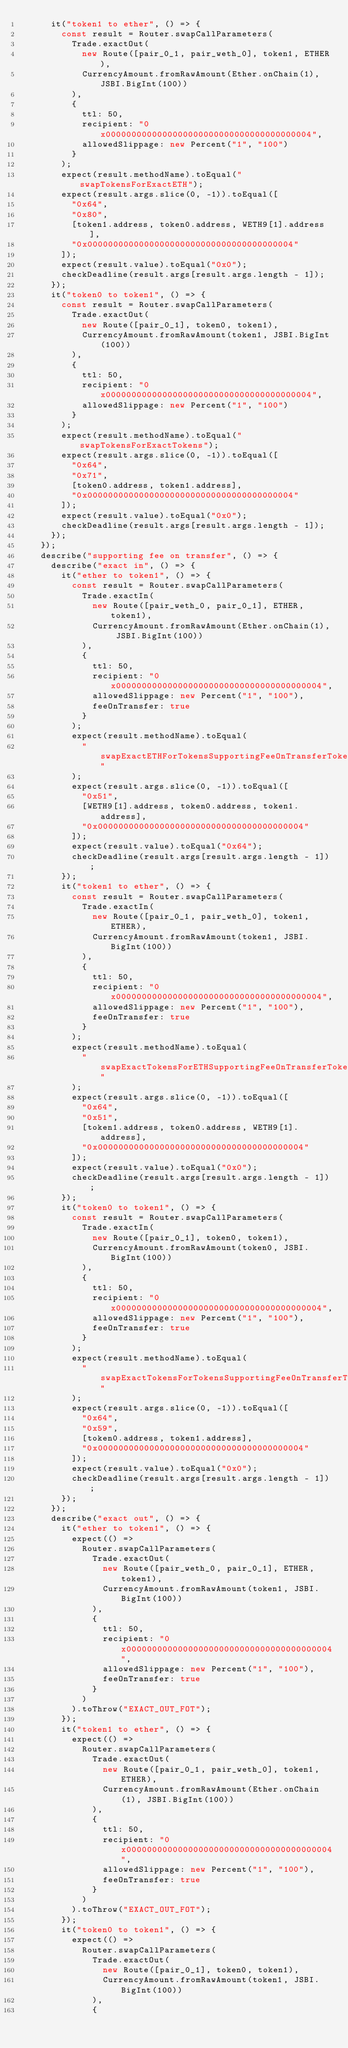Convert code to text. <code><loc_0><loc_0><loc_500><loc_500><_TypeScript_>      it("token1 to ether", () => {
        const result = Router.swapCallParameters(
          Trade.exactOut(
            new Route([pair_0_1, pair_weth_0], token1, ETHER),
            CurrencyAmount.fromRawAmount(Ether.onChain(1), JSBI.BigInt(100))
          ),
          {
            ttl: 50,
            recipient: "0x0000000000000000000000000000000000000004",
            allowedSlippage: new Percent("1", "100")
          }
        );
        expect(result.methodName).toEqual("swapTokensForExactETH");
        expect(result.args.slice(0, -1)).toEqual([
          "0x64",
          "0x80",
          [token1.address, token0.address, WETH9[1].address],
          "0x0000000000000000000000000000000000000004"
        ]);
        expect(result.value).toEqual("0x0");
        checkDeadline(result.args[result.args.length - 1]);
      });
      it("token0 to token1", () => {
        const result = Router.swapCallParameters(
          Trade.exactOut(
            new Route([pair_0_1], token0, token1),
            CurrencyAmount.fromRawAmount(token1, JSBI.BigInt(100))
          ),
          {
            ttl: 50,
            recipient: "0x0000000000000000000000000000000000000004",
            allowedSlippage: new Percent("1", "100")
          }
        );
        expect(result.methodName).toEqual("swapTokensForExactTokens");
        expect(result.args.slice(0, -1)).toEqual([
          "0x64",
          "0x71",
          [token0.address, token1.address],
          "0x0000000000000000000000000000000000000004"
        ]);
        expect(result.value).toEqual("0x0");
        checkDeadline(result.args[result.args.length - 1]);
      });
    });
    describe("supporting fee on transfer", () => {
      describe("exact in", () => {
        it("ether to token1", () => {
          const result = Router.swapCallParameters(
            Trade.exactIn(
              new Route([pair_weth_0, pair_0_1], ETHER, token1),
              CurrencyAmount.fromRawAmount(Ether.onChain(1), JSBI.BigInt(100))
            ),
            {
              ttl: 50,
              recipient: "0x0000000000000000000000000000000000000004",
              allowedSlippage: new Percent("1", "100"),
              feeOnTransfer: true
            }
          );
          expect(result.methodName).toEqual(
            "swapExactETHForTokensSupportingFeeOnTransferTokens"
          );
          expect(result.args.slice(0, -1)).toEqual([
            "0x51",
            [WETH9[1].address, token0.address, token1.address],
            "0x0000000000000000000000000000000000000004"
          ]);
          expect(result.value).toEqual("0x64");
          checkDeadline(result.args[result.args.length - 1]);
        });
        it("token1 to ether", () => {
          const result = Router.swapCallParameters(
            Trade.exactIn(
              new Route([pair_0_1, pair_weth_0], token1, ETHER),
              CurrencyAmount.fromRawAmount(token1, JSBI.BigInt(100))
            ),
            {
              ttl: 50,
              recipient: "0x0000000000000000000000000000000000000004",
              allowedSlippage: new Percent("1", "100"),
              feeOnTransfer: true
            }
          );
          expect(result.methodName).toEqual(
            "swapExactTokensForETHSupportingFeeOnTransferTokens"
          );
          expect(result.args.slice(0, -1)).toEqual([
            "0x64",
            "0x51",
            [token1.address, token0.address, WETH9[1].address],
            "0x0000000000000000000000000000000000000004"
          ]);
          expect(result.value).toEqual("0x0");
          checkDeadline(result.args[result.args.length - 1]);
        });
        it("token0 to token1", () => {
          const result = Router.swapCallParameters(
            Trade.exactIn(
              new Route([pair_0_1], token0, token1),
              CurrencyAmount.fromRawAmount(token0, JSBI.BigInt(100))
            ),
            {
              ttl: 50,
              recipient: "0x0000000000000000000000000000000000000004",
              allowedSlippage: new Percent("1", "100"),
              feeOnTransfer: true
            }
          );
          expect(result.methodName).toEqual(
            "swapExactTokensForTokensSupportingFeeOnTransferTokens"
          );
          expect(result.args.slice(0, -1)).toEqual([
            "0x64",
            "0x59",
            [token0.address, token1.address],
            "0x0000000000000000000000000000000000000004"
          ]);
          expect(result.value).toEqual("0x0");
          checkDeadline(result.args[result.args.length - 1]);
        });
      });
      describe("exact out", () => {
        it("ether to token1", () => {
          expect(() =>
            Router.swapCallParameters(
              Trade.exactOut(
                new Route([pair_weth_0, pair_0_1], ETHER, token1),
                CurrencyAmount.fromRawAmount(token1, JSBI.BigInt(100))
              ),
              {
                ttl: 50,
                recipient: "0x0000000000000000000000000000000000000004",
                allowedSlippage: new Percent("1", "100"),
                feeOnTransfer: true
              }
            )
          ).toThrow("EXACT_OUT_FOT");
        });
        it("token1 to ether", () => {
          expect(() =>
            Router.swapCallParameters(
              Trade.exactOut(
                new Route([pair_0_1, pair_weth_0], token1, ETHER),
                CurrencyAmount.fromRawAmount(Ether.onChain(1), JSBI.BigInt(100))
              ),
              {
                ttl: 50,
                recipient: "0x0000000000000000000000000000000000000004",
                allowedSlippage: new Percent("1", "100"),
                feeOnTransfer: true
              }
            )
          ).toThrow("EXACT_OUT_FOT");
        });
        it("token0 to token1", () => {
          expect(() =>
            Router.swapCallParameters(
              Trade.exactOut(
                new Route([pair_0_1], token0, token1),
                CurrencyAmount.fromRawAmount(token1, JSBI.BigInt(100))
              ),
              {</code> 